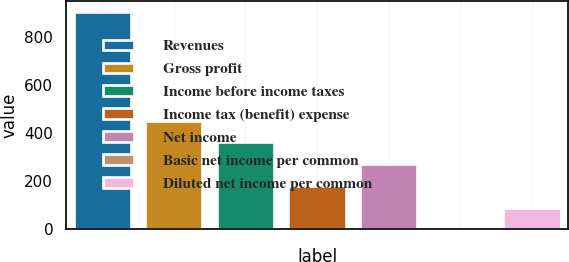Convert chart to OTSL. <chart><loc_0><loc_0><loc_500><loc_500><bar_chart><fcel>Revenues<fcel>Gross profit<fcel>Income before income taxes<fcel>Income tax (benefit) expense<fcel>Net income<fcel>Basic net income per common<fcel>Diluted net income per common<nl><fcel>906.6<fcel>453.34<fcel>362.69<fcel>181.39<fcel>272.04<fcel>0.09<fcel>90.74<nl></chart> 